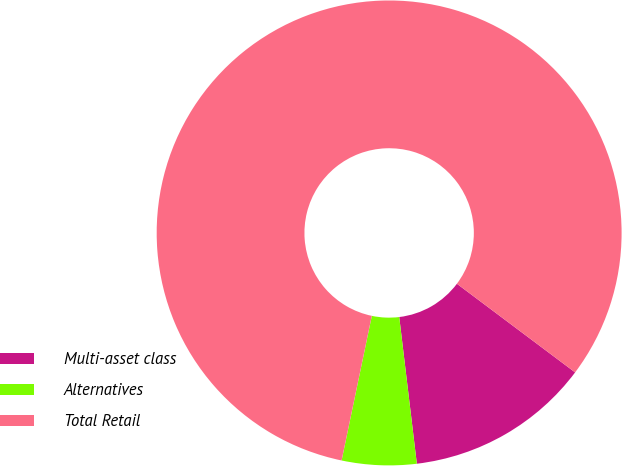Convert chart to OTSL. <chart><loc_0><loc_0><loc_500><loc_500><pie_chart><fcel>Multi-asset class<fcel>Alternatives<fcel>Total Retail<nl><fcel>12.86%<fcel>5.18%<fcel>81.97%<nl></chart> 